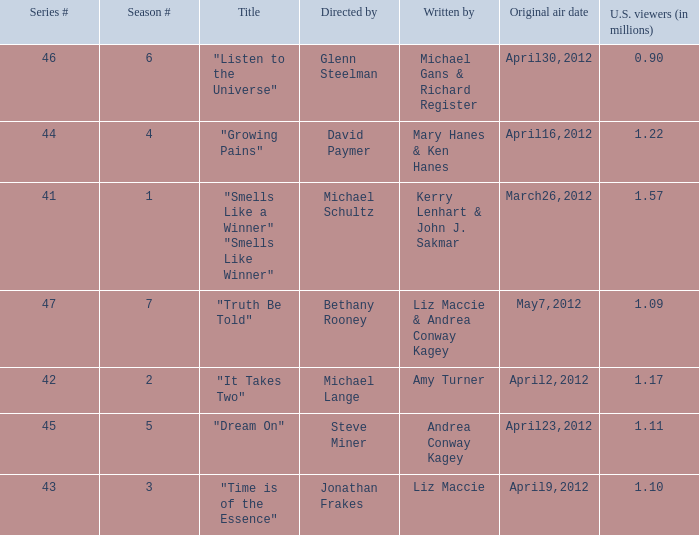What is the title of the episode/s written by Michael Gans & Richard Register? "Listen to the Universe". 